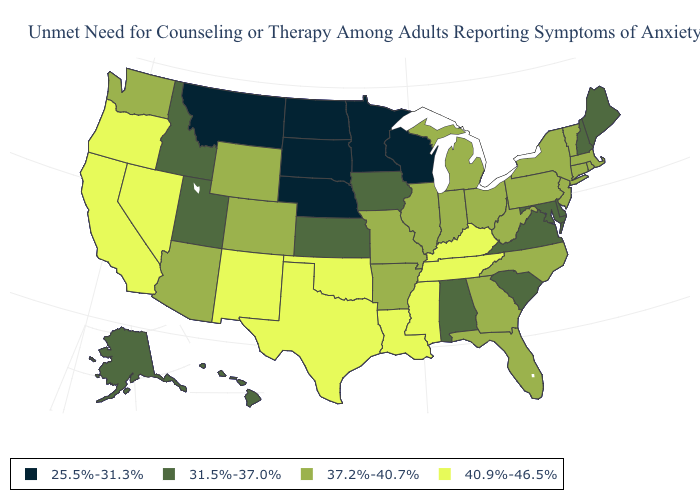Does Vermont have the same value as Arkansas?
Be succinct. Yes. What is the value of Iowa?
Concise answer only. 31.5%-37.0%. Name the states that have a value in the range 31.5%-37.0%?
Give a very brief answer. Alabama, Alaska, Delaware, Hawaii, Idaho, Iowa, Kansas, Maine, Maryland, New Hampshire, South Carolina, Utah, Virginia. Name the states that have a value in the range 40.9%-46.5%?
Concise answer only. California, Kentucky, Louisiana, Mississippi, Nevada, New Mexico, Oklahoma, Oregon, Tennessee, Texas. Does the map have missing data?
Give a very brief answer. No. Does Maryland have the lowest value in the USA?
Keep it brief. No. How many symbols are there in the legend?
Concise answer only. 4. Does Oregon have the highest value in the USA?
Keep it brief. Yes. Name the states that have a value in the range 25.5%-31.3%?
Short answer required. Minnesota, Montana, Nebraska, North Dakota, South Dakota, Wisconsin. Is the legend a continuous bar?
Be succinct. No. Name the states that have a value in the range 31.5%-37.0%?
Write a very short answer. Alabama, Alaska, Delaware, Hawaii, Idaho, Iowa, Kansas, Maine, Maryland, New Hampshire, South Carolina, Utah, Virginia. Does Michigan have a lower value than Washington?
Give a very brief answer. No. What is the highest value in the USA?
Short answer required. 40.9%-46.5%. Name the states that have a value in the range 40.9%-46.5%?
Answer briefly. California, Kentucky, Louisiana, Mississippi, Nevada, New Mexico, Oklahoma, Oregon, Tennessee, Texas. Does the first symbol in the legend represent the smallest category?
Answer briefly. Yes. 